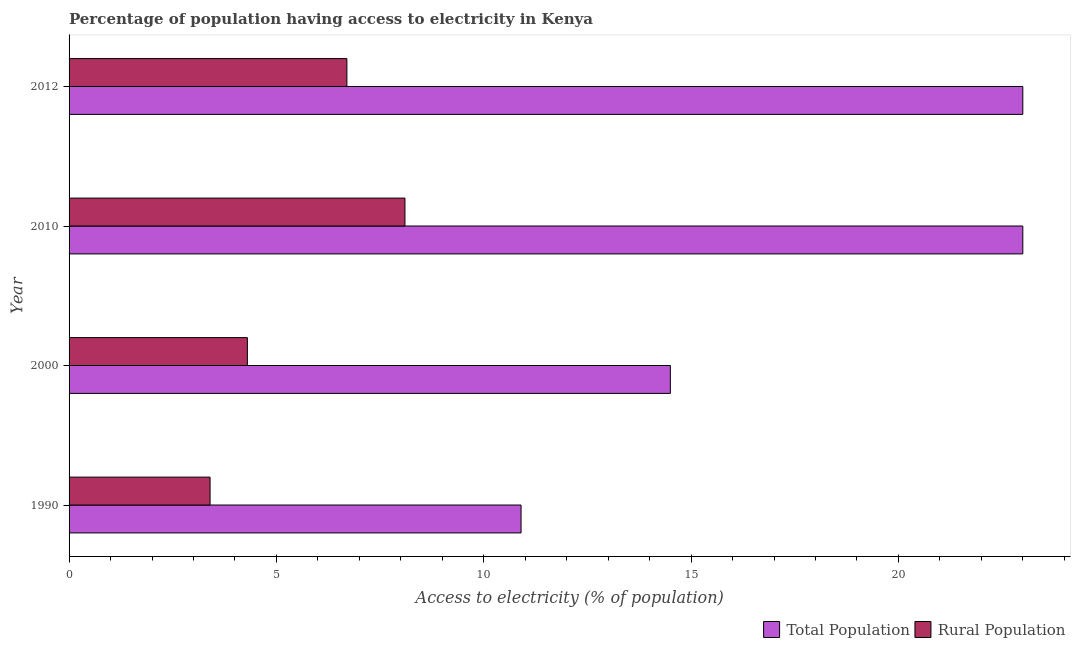How many different coloured bars are there?
Offer a very short reply. 2. Are the number of bars on each tick of the Y-axis equal?
Keep it short and to the point. Yes. How many bars are there on the 4th tick from the bottom?
Keep it short and to the point. 2. What is the label of the 2nd group of bars from the top?
Offer a terse response. 2010. In how many cases, is the number of bars for a given year not equal to the number of legend labels?
Offer a very short reply. 0. Across all years, what is the minimum percentage of rural population having access to electricity?
Provide a succinct answer. 3.4. In which year was the percentage of rural population having access to electricity maximum?
Give a very brief answer. 2010. In which year was the percentage of population having access to electricity minimum?
Your answer should be compact. 1990. What is the total percentage of rural population having access to electricity in the graph?
Provide a succinct answer. 22.5. What is the difference between the percentage of population having access to electricity in 2000 and that in 2010?
Your answer should be compact. -8.5. What is the difference between the percentage of rural population having access to electricity in 2010 and the percentage of population having access to electricity in 1990?
Give a very brief answer. -2.8. What is the average percentage of rural population having access to electricity per year?
Your answer should be very brief. 5.62. In the year 2012, what is the difference between the percentage of rural population having access to electricity and percentage of population having access to electricity?
Your answer should be very brief. -16.3. What is the ratio of the percentage of rural population having access to electricity in 1990 to that in 2010?
Make the answer very short. 0.42. Is the percentage of rural population having access to electricity in 2010 less than that in 2012?
Provide a short and direct response. No. Is the difference between the percentage of rural population having access to electricity in 1990 and 2010 greater than the difference between the percentage of population having access to electricity in 1990 and 2010?
Provide a short and direct response. Yes. What is the difference between the highest and the lowest percentage of population having access to electricity?
Give a very brief answer. 12.1. In how many years, is the percentage of rural population having access to electricity greater than the average percentage of rural population having access to electricity taken over all years?
Your answer should be very brief. 2. Is the sum of the percentage of rural population having access to electricity in 2010 and 2012 greater than the maximum percentage of population having access to electricity across all years?
Ensure brevity in your answer.  No. What does the 2nd bar from the top in 1990 represents?
Your answer should be compact. Total Population. What does the 2nd bar from the bottom in 2000 represents?
Provide a succinct answer. Rural Population. How many bars are there?
Provide a succinct answer. 8. How many years are there in the graph?
Offer a very short reply. 4. What is the difference between two consecutive major ticks on the X-axis?
Give a very brief answer. 5. Are the values on the major ticks of X-axis written in scientific E-notation?
Provide a short and direct response. No. Does the graph contain any zero values?
Offer a terse response. No. How are the legend labels stacked?
Your answer should be compact. Horizontal. What is the title of the graph?
Ensure brevity in your answer.  Percentage of population having access to electricity in Kenya. Does "Total Population" appear as one of the legend labels in the graph?
Offer a terse response. Yes. What is the label or title of the X-axis?
Your answer should be very brief. Access to electricity (% of population). What is the Access to electricity (% of population) of Total Population in 1990?
Ensure brevity in your answer.  10.9. What is the Access to electricity (% of population) in Total Population in 2000?
Provide a short and direct response. 14.5. What is the Access to electricity (% of population) in Rural Population in 2000?
Give a very brief answer. 4.3. What is the Access to electricity (% of population) in Total Population in 2010?
Give a very brief answer. 23. What is the Access to electricity (% of population) in Total Population in 2012?
Give a very brief answer. 23. Across all years, what is the maximum Access to electricity (% of population) in Total Population?
Keep it short and to the point. 23. Across all years, what is the maximum Access to electricity (% of population) of Rural Population?
Your answer should be very brief. 8.1. What is the total Access to electricity (% of population) of Total Population in the graph?
Provide a short and direct response. 71.4. What is the difference between the Access to electricity (% of population) of Rural Population in 1990 and that in 2000?
Offer a very short reply. -0.9. What is the difference between the Access to electricity (% of population) in Total Population in 1990 and that in 2010?
Provide a short and direct response. -12.1. What is the difference between the Access to electricity (% of population) of Rural Population in 1990 and that in 2010?
Keep it short and to the point. -4.7. What is the difference between the Access to electricity (% of population) in Total Population in 1990 and that in 2012?
Your response must be concise. -12.1. What is the difference between the Access to electricity (% of population) in Rural Population in 2000 and that in 2010?
Provide a short and direct response. -3.8. What is the difference between the Access to electricity (% of population) of Total Population in 2010 and that in 2012?
Offer a terse response. 0. What is the difference between the Access to electricity (% of population) of Total Population in 1990 and the Access to electricity (% of population) of Rural Population in 2012?
Give a very brief answer. 4.2. What is the difference between the Access to electricity (% of population) of Total Population in 2000 and the Access to electricity (% of population) of Rural Population in 2012?
Keep it short and to the point. 7.8. What is the difference between the Access to electricity (% of population) of Total Population in 2010 and the Access to electricity (% of population) of Rural Population in 2012?
Your answer should be compact. 16.3. What is the average Access to electricity (% of population) in Total Population per year?
Provide a succinct answer. 17.85. What is the average Access to electricity (% of population) of Rural Population per year?
Give a very brief answer. 5.62. In the year 1990, what is the difference between the Access to electricity (% of population) of Total Population and Access to electricity (% of population) of Rural Population?
Give a very brief answer. 7.5. In the year 2000, what is the difference between the Access to electricity (% of population) in Total Population and Access to electricity (% of population) in Rural Population?
Your response must be concise. 10.2. In the year 2012, what is the difference between the Access to electricity (% of population) of Total Population and Access to electricity (% of population) of Rural Population?
Offer a very short reply. 16.3. What is the ratio of the Access to electricity (% of population) in Total Population in 1990 to that in 2000?
Offer a terse response. 0.75. What is the ratio of the Access to electricity (% of population) in Rural Population in 1990 to that in 2000?
Make the answer very short. 0.79. What is the ratio of the Access to electricity (% of population) of Total Population in 1990 to that in 2010?
Offer a terse response. 0.47. What is the ratio of the Access to electricity (% of population) of Rural Population in 1990 to that in 2010?
Give a very brief answer. 0.42. What is the ratio of the Access to electricity (% of population) in Total Population in 1990 to that in 2012?
Provide a short and direct response. 0.47. What is the ratio of the Access to electricity (% of population) of Rural Population in 1990 to that in 2012?
Provide a succinct answer. 0.51. What is the ratio of the Access to electricity (% of population) of Total Population in 2000 to that in 2010?
Your response must be concise. 0.63. What is the ratio of the Access to electricity (% of population) in Rural Population in 2000 to that in 2010?
Your response must be concise. 0.53. What is the ratio of the Access to electricity (% of population) in Total Population in 2000 to that in 2012?
Keep it short and to the point. 0.63. What is the ratio of the Access to electricity (% of population) in Rural Population in 2000 to that in 2012?
Offer a terse response. 0.64. What is the ratio of the Access to electricity (% of population) in Total Population in 2010 to that in 2012?
Your response must be concise. 1. What is the ratio of the Access to electricity (% of population) of Rural Population in 2010 to that in 2012?
Your response must be concise. 1.21. What is the difference between the highest and the second highest Access to electricity (% of population) in Total Population?
Your answer should be very brief. 0. What is the difference between the highest and the lowest Access to electricity (% of population) of Total Population?
Your response must be concise. 12.1. 